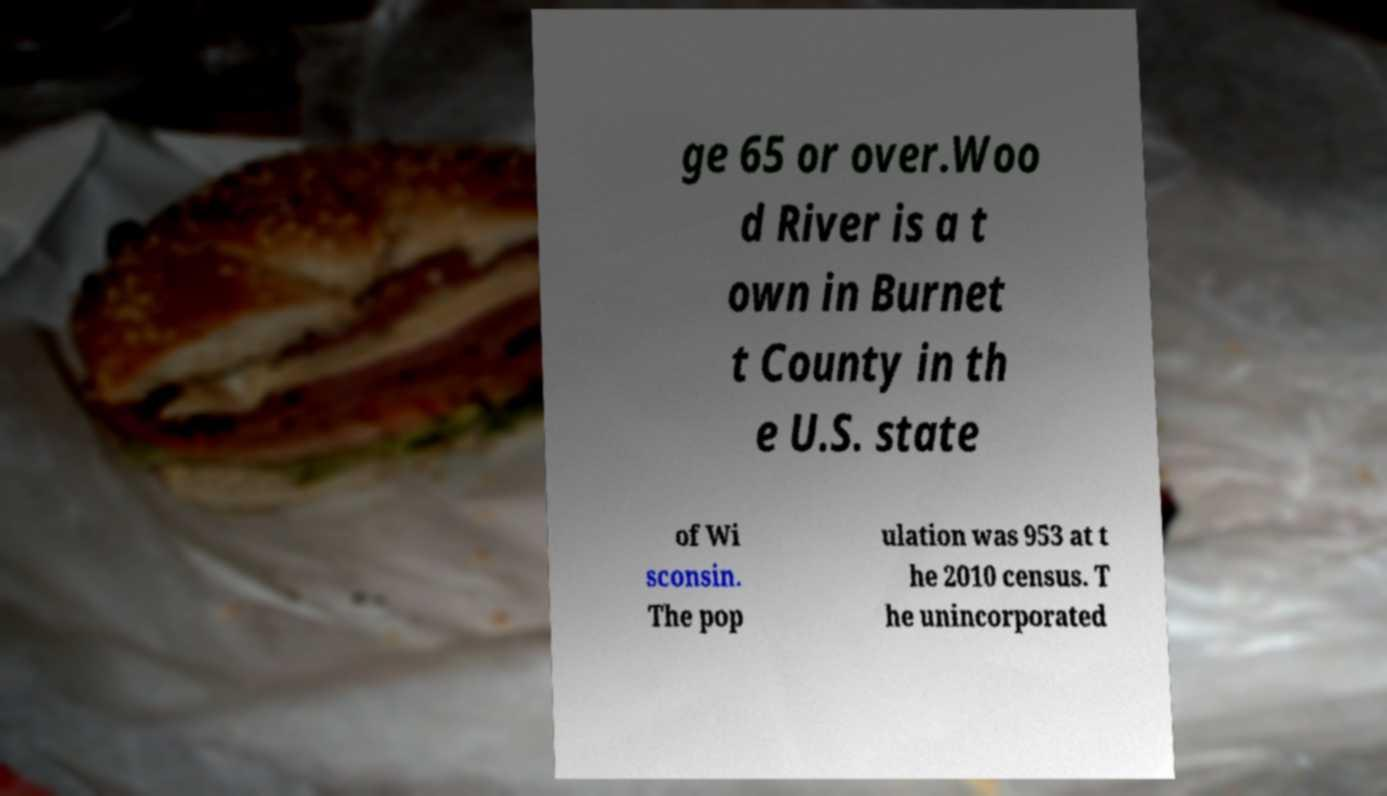I need the written content from this picture converted into text. Can you do that? ge 65 or over.Woo d River is a t own in Burnet t County in th e U.S. state of Wi sconsin. The pop ulation was 953 at t he 2010 census. T he unincorporated 